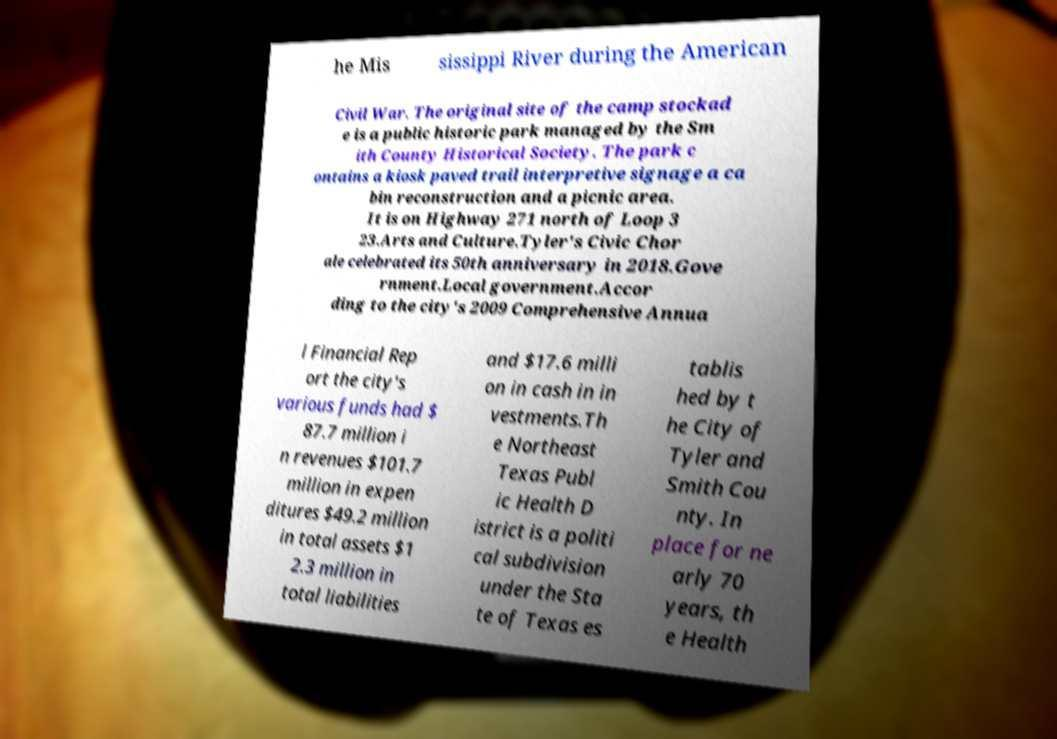For documentation purposes, I need the text within this image transcribed. Could you provide that? he Mis sissippi River during the American Civil War. The original site of the camp stockad e is a public historic park managed by the Sm ith County Historical Society. The park c ontains a kiosk paved trail interpretive signage a ca bin reconstruction and a picnic area. It is on Highway 271 north of Loop 3 23.Arts and Culture.Tyler's Civic Chor ale celebrated its 50th anniversary in 2018.Gove rnment.Local government.Accor ding to the city's 2009 Comprehensive Annua l Financial Rep ort the city's various funds had $ 87.7 million i n revenues $101.7 million in expen ditures $49.2 million in total assets $1 2.3 million in total liabilities and $17.6 milli on in cash in in vestments.Th e Northeast Texas Publ ic Health D istrict is a politi cal subdivision under the Sta te of Texas es tablis hed by t he City of Tyler and Smith Cou nty. In place for ne arly 70 years, th e Health 